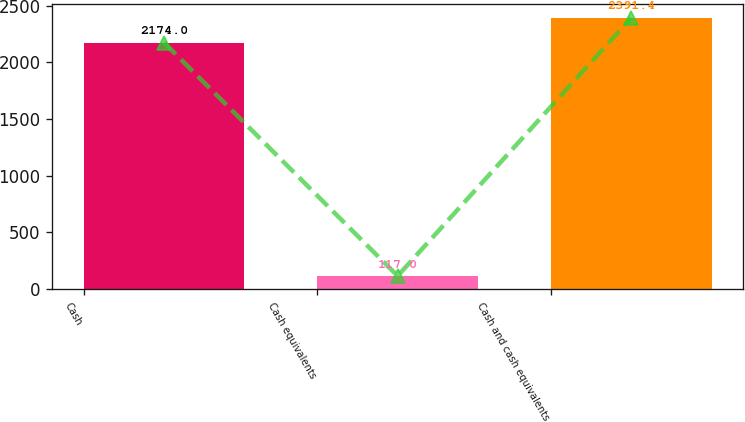Convert chart. <chart><loc_0><loc_0><loc_500><loc_500><bar_chart><fcel>Cash<fcel>Cash equivalents<fcel>Cash and cash equivalents<nl><fcel>2174<fcel>117<fcel>2391.4<nl></chart> 